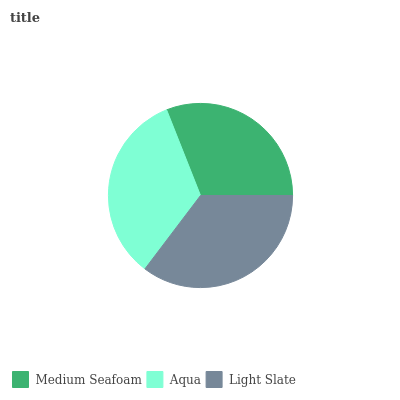Is Medium Seafoam the minimum?
Answer yes or no. Yes. Is Light Slate the maximum?
Answer yes or no. Yes. Is Aqua the minimum?
Answer yes or no. No. Is Aqua the maximum?
Answer yes or no. No. Is Aqua greater than Medium Seafoam?
Answer yes or no. Yes. Is Medium Seafoam less than Aqua?
Answer yes or no. Yes. Is Medium Seafoam greater than Aqua?
Answer yes or no. No. Is Aqua less than Medium Seafoam?
Answer yes or no. No. Is Aqua the high median?
Answer yes or no. Yes. Is Aqua the low median?
Answer yes or no. Yes. Is Light Slate the high median?
Answer yes or no. No. Is Medium Seafoam the low median?
Answer yes or no. No. 